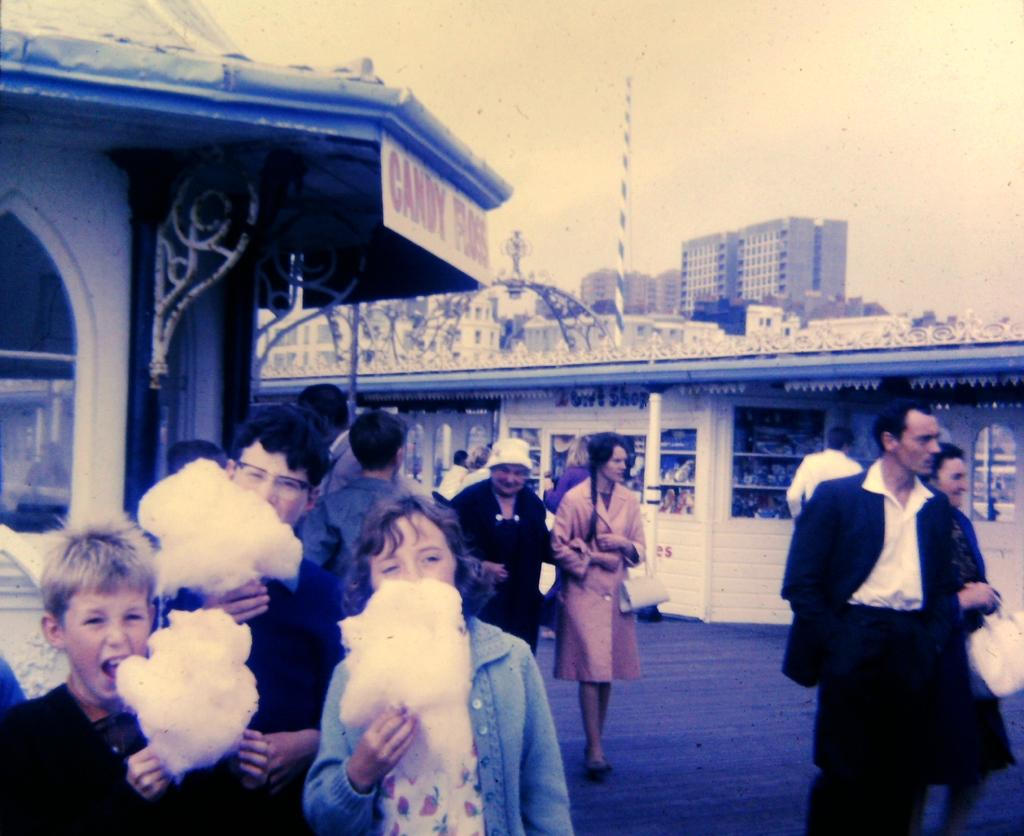What are the people in the image doing? There are many people walking on the land in the image. Can you describe a specific group of people in the image? There are three people eating cotton candy on the left side of the image. What can be seen in the distance behind the people? There are buildings visible in the background of the image. What is visible above the scene in the image? The sky is visible above the scene in the image. What type of news can be heard coming from the elbow in the image? There is no elbow present in the image, and therefore no news can be heard from it. 